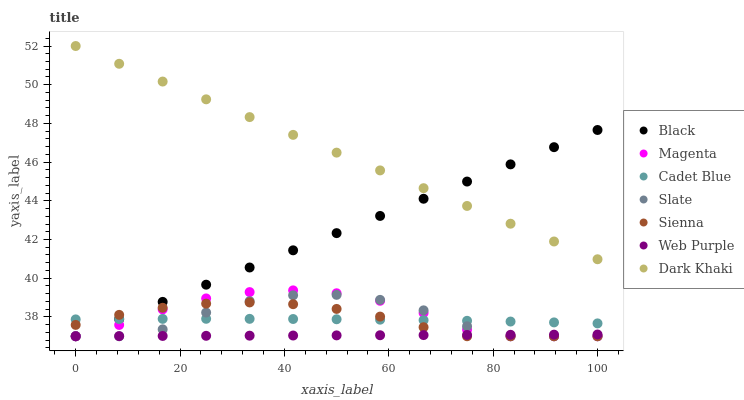Does Web Purple have the minimum area under the curve?
Answer yes or no. Yes. Does Dark Khaki have the maximum area under the curve?
Answer yes or no. Yes. Does Cadet Blue have the minimum area under the curve?
Answer yes or no. No. Does Cadet Blue have the maximum area under the curve?
Answer yes or no. No. Is Dark Khaki the smoothest?
Answer yes or no. Yes. Is Slate the roughest?
Answer yes or no. Yes. Is Cadet Blue the smoothest?
Answer yes or no. No. Is Cadet Blue the roughest?
Answer yes or no. No. Does Slate have the lowest value?
Answer yes or no. Yes. Does Cadet Blue have the lowest value?
Answer yes or no. No. Does Dark Khaki have the highest value?
Answer yes or no. Yes. Does Cadet Blue have the highest value?
Answer yes or no. No. Is Sienna less than Dark Khaki?
Answer yes or no. Yes. Is Dark Khaki greater than Cadet Blue?
Answer yes or no. Yes. Does Dark Khaki intersect Black?
Answer yes or no. Yes. Is Dark Khaki less than Black?
Answer yes or no. No. Is Dark Khaki greater than Black?
Answer yes or no. No. Does Sienna intersect Dark Khaki?
Answer yes or no. No. 